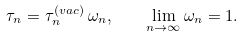Convert formula to latex. <formula><loc_0><loc_0><loc_500><loc_500>\tau _ { n } = \tau _ { n } ^ { ( v a c ) } \, \omega _ { n } , \quad \lim _ { n \to \infty } \omega _ { n } = 1 .</formula> 